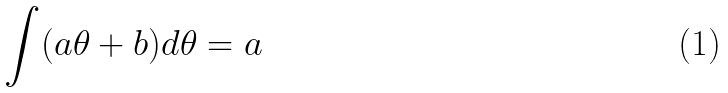Convert formula to latex. <formula><loc_0><loc_0><loc_500><loc_500>\int ( a \theta + b ) d \theta = a</formula> 